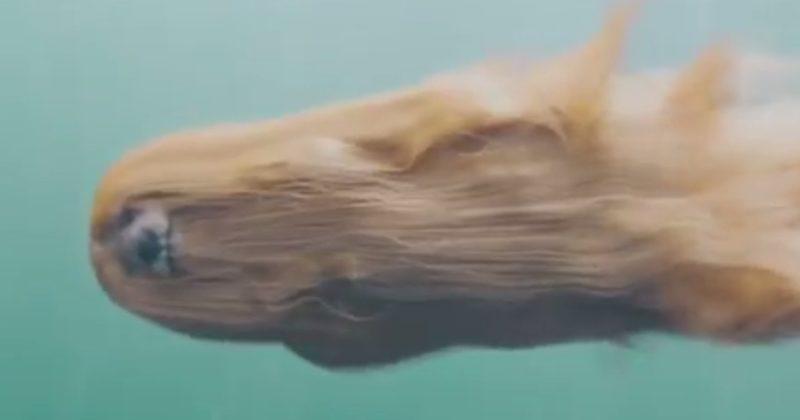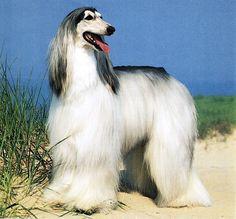The first image is the image on the left, the second image is the image on the right. For the images shown, is this caption "A dog is completely submerged in the water." true? Answer yes or no. Yes. The first image is the image on the left, the second image is the image on the right. For the images displayed, is the sentence "One image shows a dog underwater and sideways, with its head to the left and its long fur trailing rightward." factually correct? Answer yes or no. Yes. 